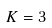<formula> <loc_0><loc_0><loc_500><loc_500>K = 3</formula> 